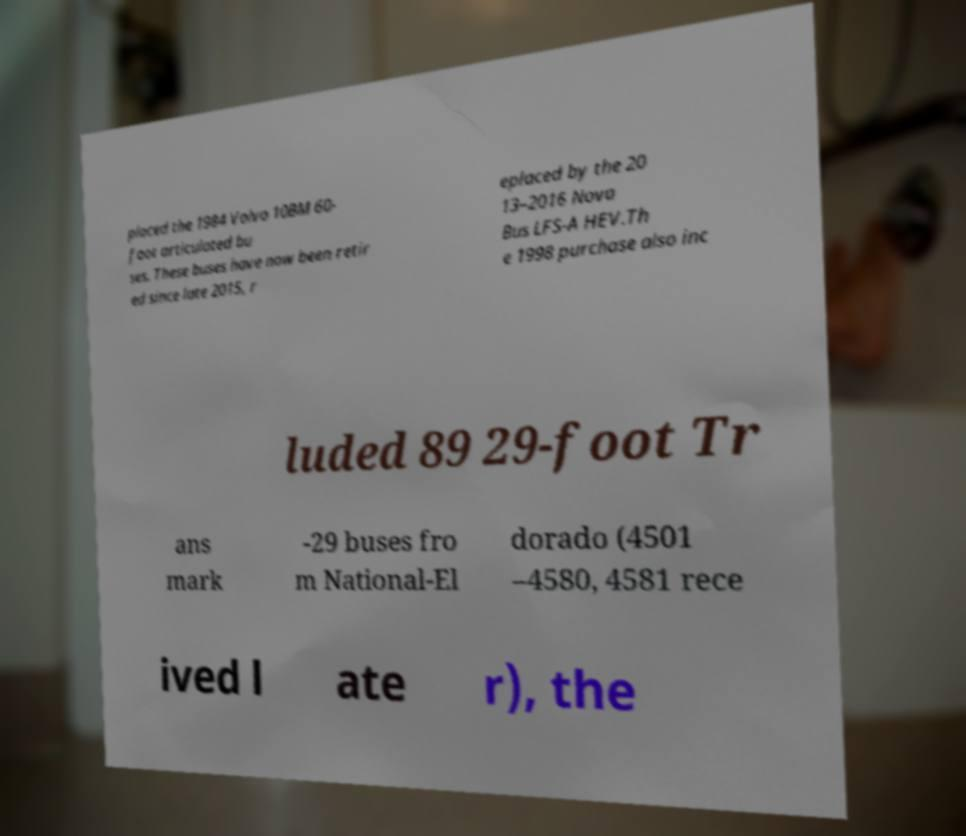There's text embedded in this image that I need extracted. Can you transcribe it verbatim? placed the 1984 Volvo 10BM 60- foot articulated bu ses. These buses have now been retir ed since late 2015, r eplaced by the 20 13–2016 Nova Bus LFS-A HEV.Th e 1998 purchase also inc luded 89 29-foot Tr ans mark -29 buses fro m National-El dorado (4501 –4580, 4581 rece ived l ate r), the 